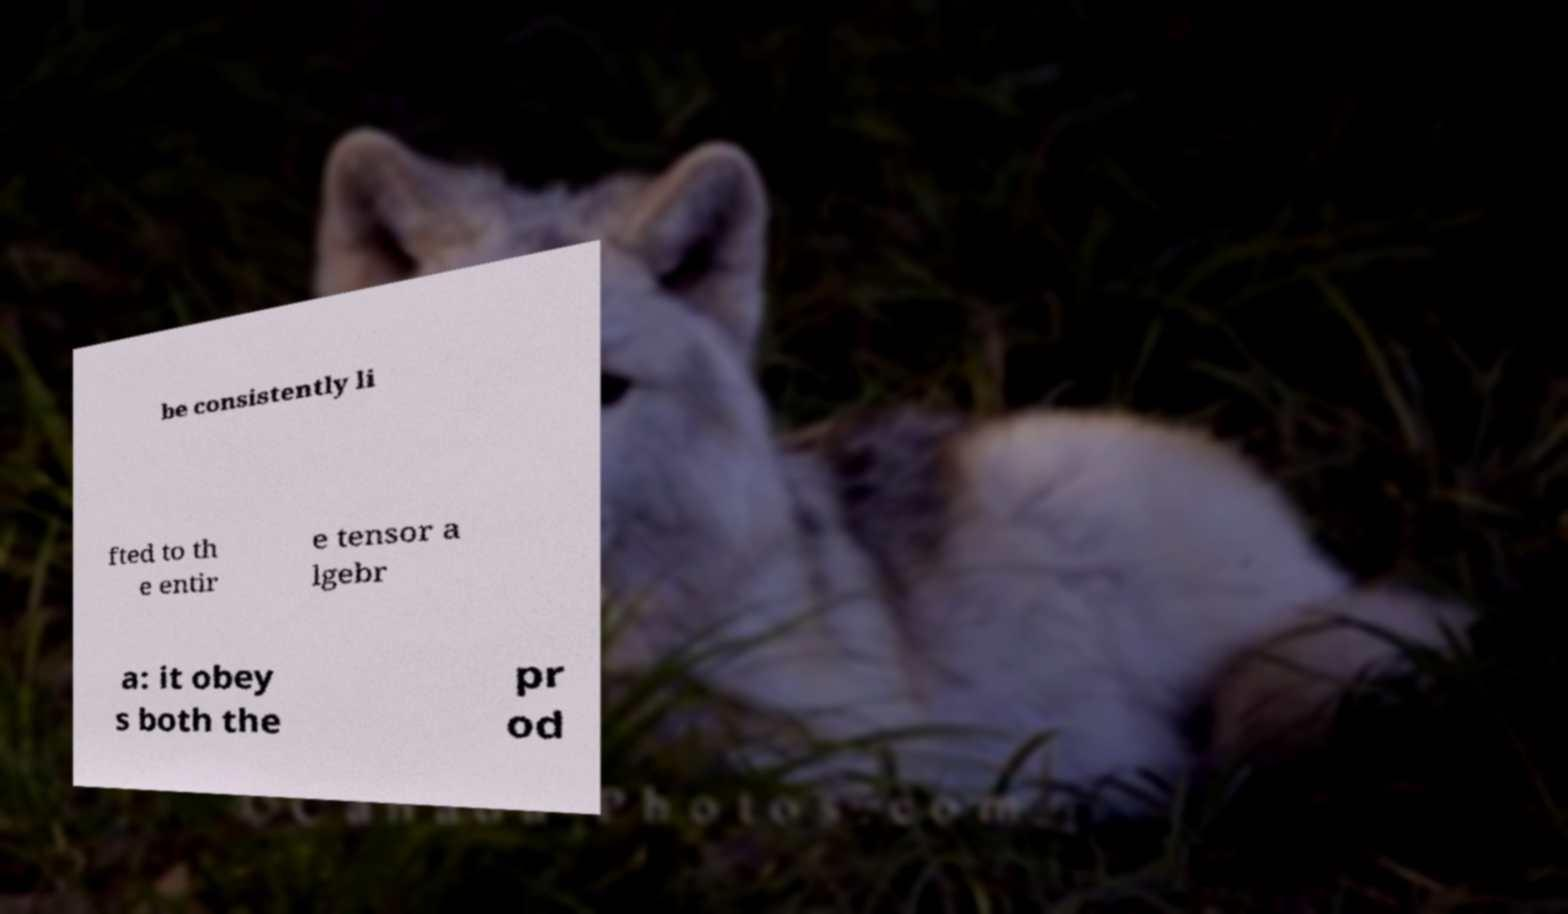Please identify and transcribe the text found in this image. be consistently li fted to th e entir e tensor a lgebr a: it obey s both the pr od 